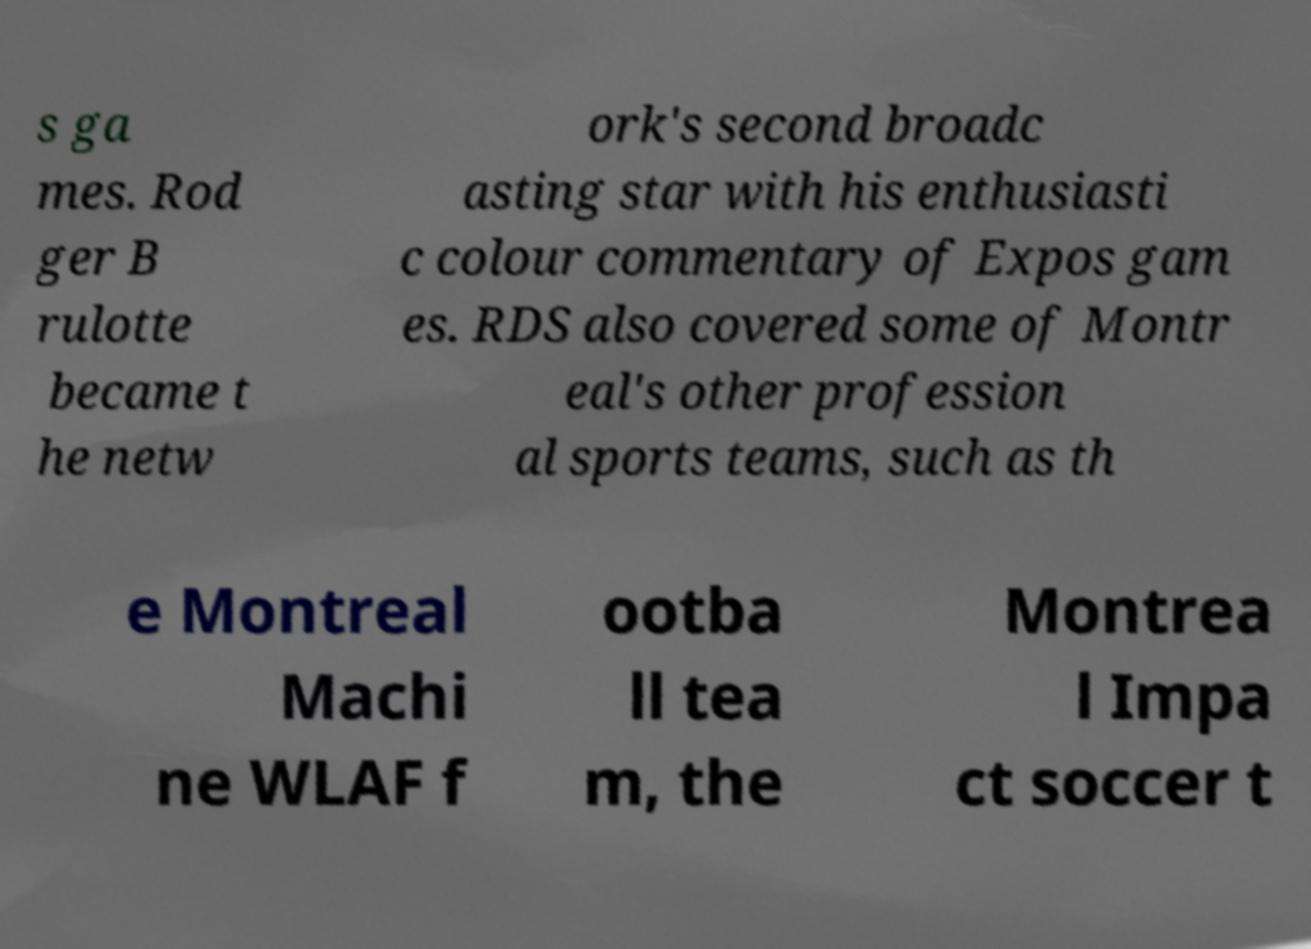Could you extract and type out the text from this image? s ga mes. Rod ger B rulotte became t he netw ork's second broadc asting star with his enthusiasti c colour commentary of Expos gam es. RDS also covered some of Montr eal's other profession al sports teams, such as th e Montreal Machi ne WLAF f ootba ll tea m, the Montrea l Impa ct soccer t 